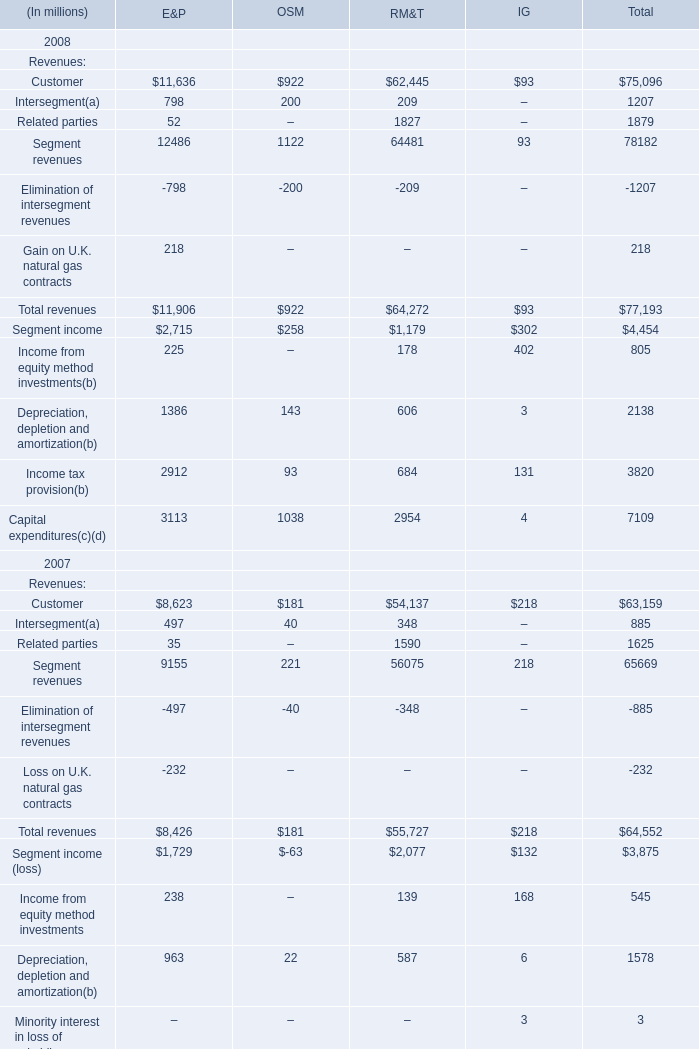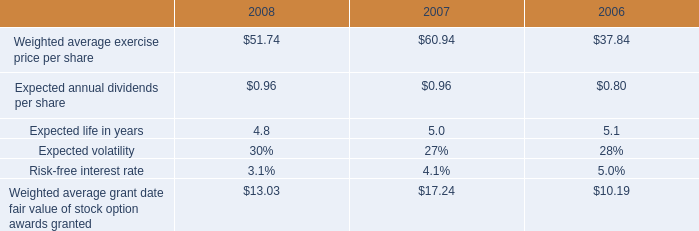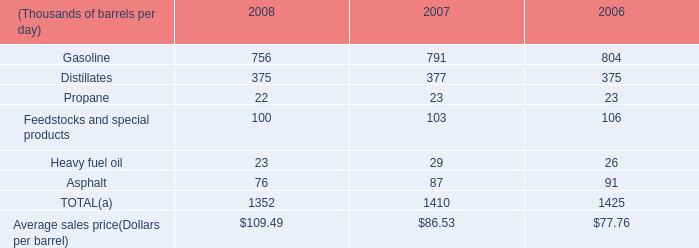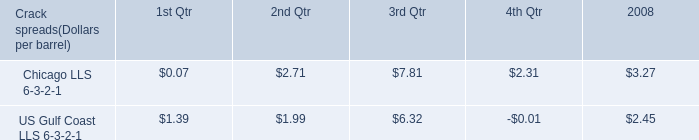what was the increase of blended ethanol into gasoline in 2008 from 2007 , in mmboe? 
Computations: (57 - 41)
Answer: 16.0. 